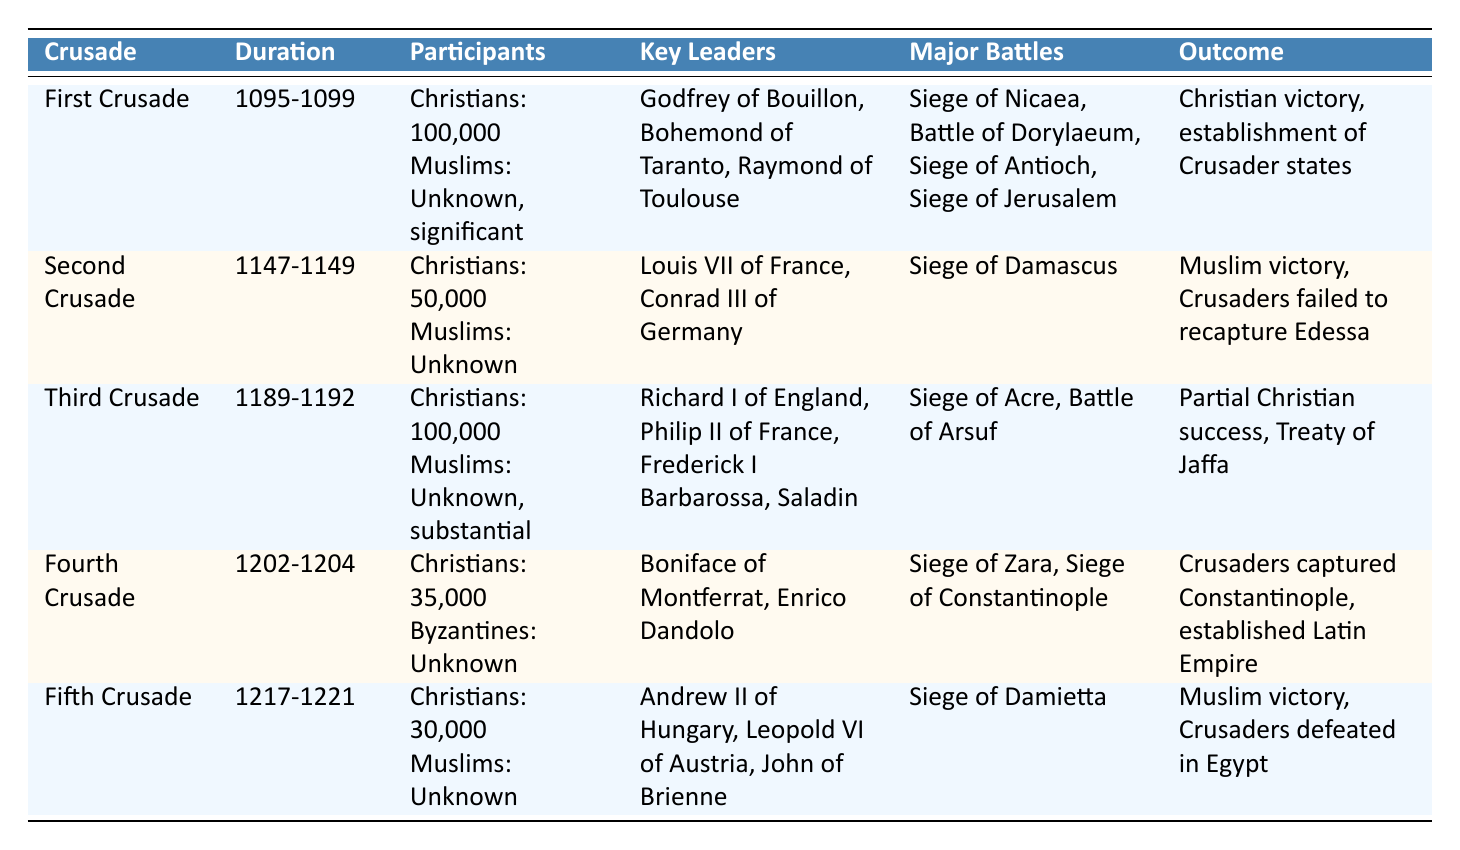What was the duration of the First Crusade? The duration for the First Crusade is listed in the table as 1095-1099.
Answer: 1095-1099 Who were the key leaders of the Third Crusade? The table provides the key leaders of the Third Crusade, which are Richard I of England, Philip II of France, Frederick I Barbarossa, and Saladin.
Answer: Richard I of England, Philip II of France, Frederick I Barbarossa, Saladin Which Crusade had the least participants based on the table? By comparing the number of participants in each Crusade, the Fifth Crusade had approximately 30,000 Christians, which is lesser than others listed.
Answer: Fifth Crusade Did the Second Crusade result in a Christian victory? According to the outcome of the Second Crusade in the table, it resulted in a Muslim victory, indicating that the Crusaders did not achieve their goals.
Answer: No What is the total estimated number of Christian participants in the First, Third, and Fifth Crusades combined? Summing up the number of Christian participants: First Crusade (approximately 100,000) + Third Crusade (approximately 100,000) + Fifth Crusade (approximately 30,000) equals 330,000. Therefore, the total is approximately 330,000.
Answer: Approximately 330,000 Which Crusades resulted in a Muslim victory? The table indicates that the Second Crusade and the Fifth Crusade both resulted in Muslim victories, as mentioned in their outcomes.
Answer: Second Crusade and Fifth Crusade What major battles took place during the Fourth Crusade? The major battles listed for the Fourth Crusade are the Siege of Zara and the Siege of Constantinople, which can be found in the respective row in the table.
Answer: Siege of Zara, Siege of Constantinople Was the establishment of Crusader states an outcome of the Fourth Crusade? By checking the outcome for the Fourth Crusade in the table, it shows that the Crusaders captured Constantinople and established the Latin Empire, not Crusader states; hence, the answer is no.
Answer: No Which Crusade had leaders from France and Germany? The Second Crusade saw leaders Louis VII of France and Conrad III of Germany, as mentioned in the key leaders section for that Crusade in the table.
Answer: Second Crusade 